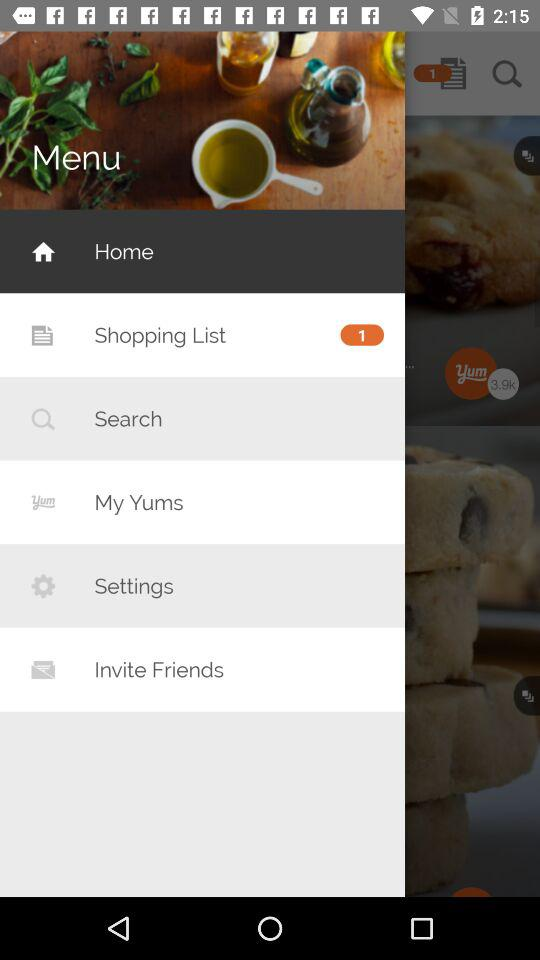How many items are on the shopping list? There is 1 item. 